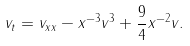<formula> <loc_0><loc_0><loc_500><loc_500>v _ { t } = v _ { x x } - x ^ { - 3 } v ^ { 3 } + \frac { 9 } { 4 } x ^ { - 2 } v .</formula> 